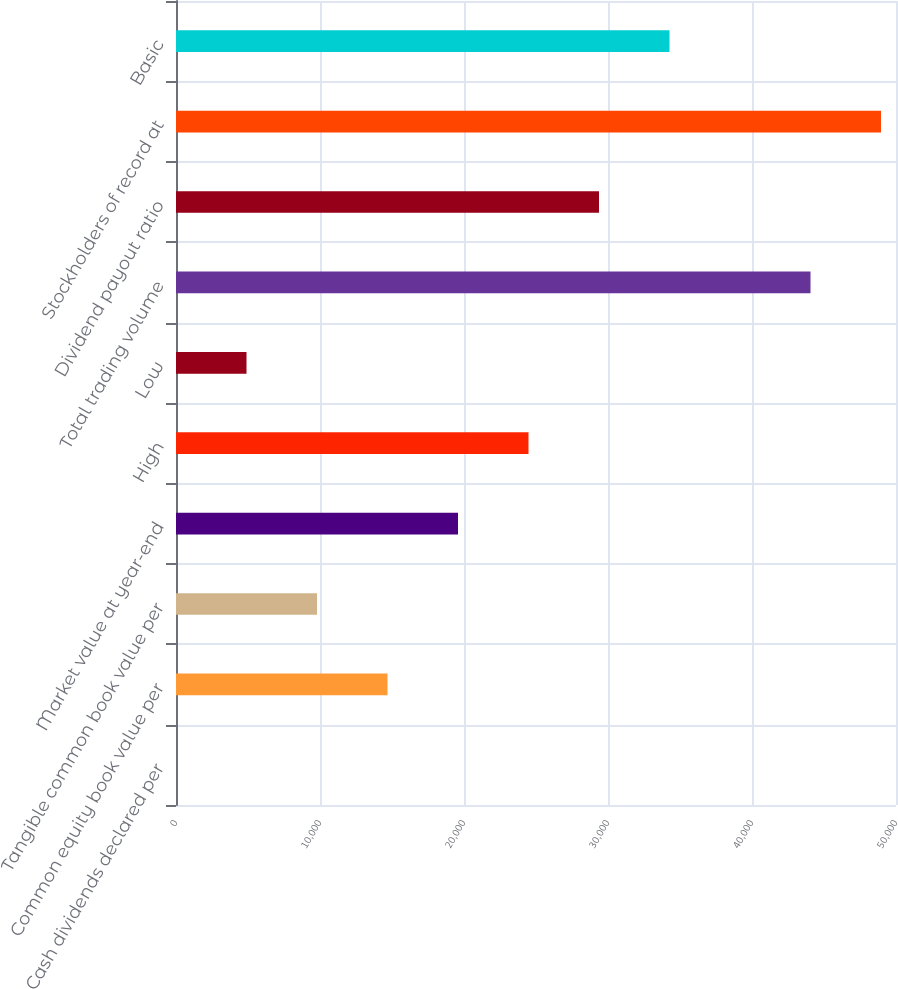Convert chart to OTSL. <chart><loc_0><loc_0><loc_500><loc_500><bar_chart><fcel>Cash dividends declared per<fcel>Common equity book value per<fcel>Tangible common book value per<fcel>Market value at year-end<fcel>High<fcel>Low<fcel>Total trading volume<fcel>Dividend payout ratio<fcel>Stockholders of record at<fcel>Basic<nl><fcel>0.26<fcel>14687.6<fcel>9791.8<fcel>19583.3<fcel>24479.1<fcel>4896.03<fcel>44062.2<fcel>29374.9<fcel>48958<fcel>34270.7<nl></chart> 